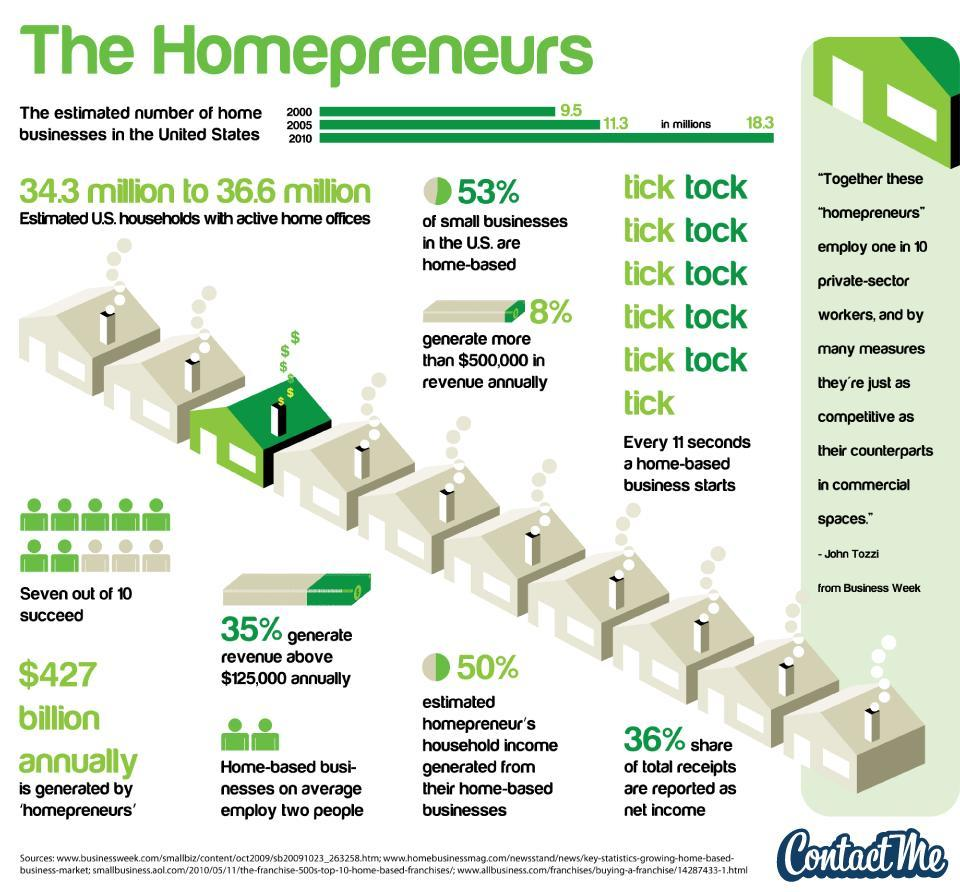What percentage of income is obtained from a business run out of a home, 35%, 36% or 50%?,
Answer the question with a short phrase. 50% 